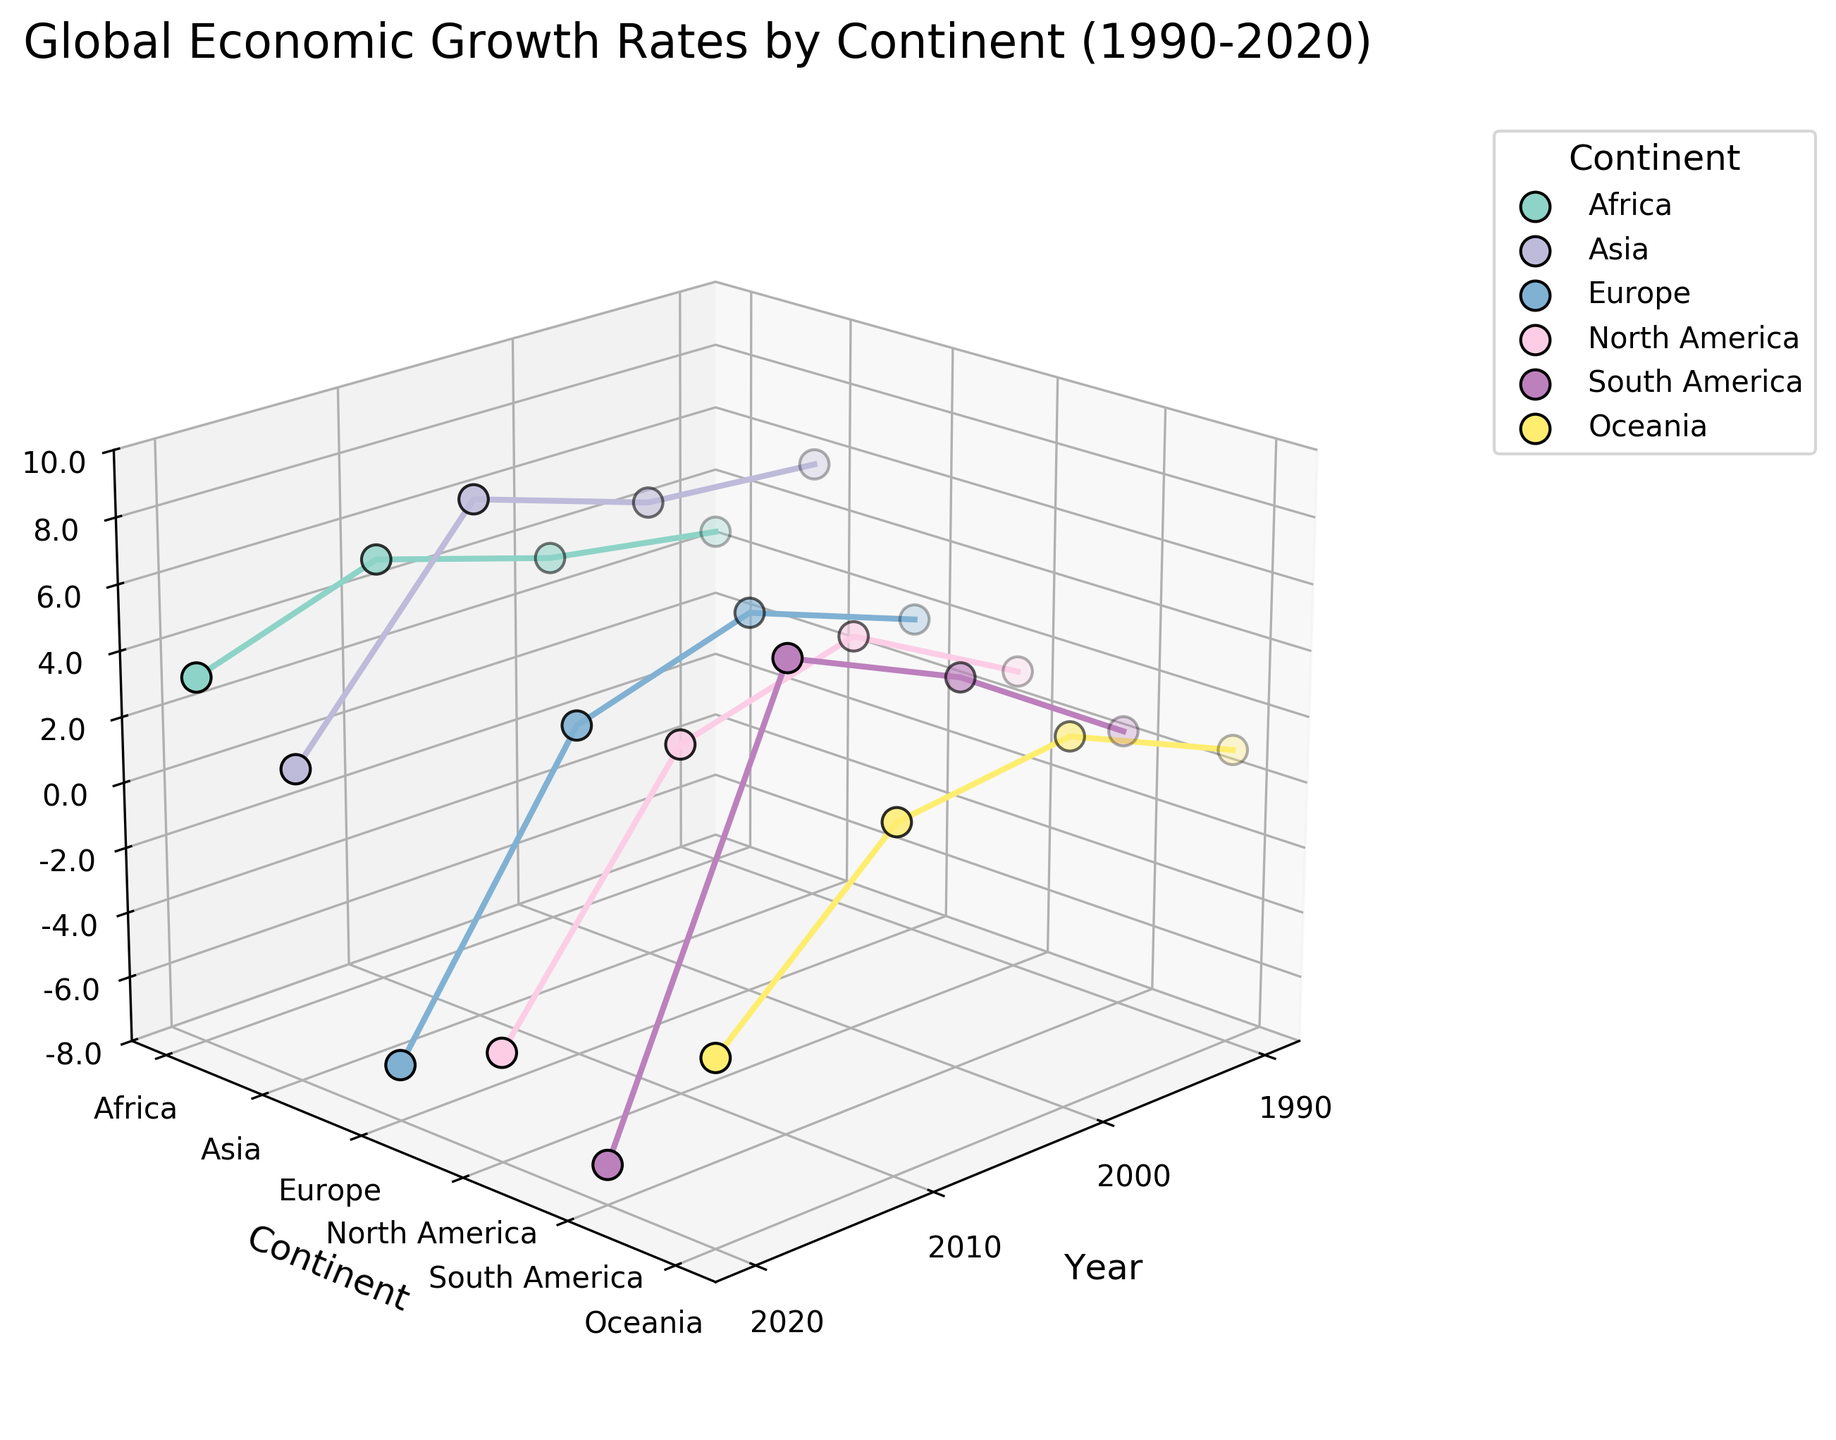What is the title of the figure? The title of the figure is displayed at the top of the plot. It is "Global Economic Growth Rates by Continent (1990-2020)."
Answer: Global Economic Growth Rates by Continent (1990-2020) Which continent had the highest growth rate in 2010? To determine this, look along the 2010 axis and compare the heights of the data points for each continent. The highest point in 2010 corresponds to Asia with a growth rate of 7.9%.
Answer: Asia What is the trend of growth rates for Africa from 1990 to 2020? Observe the data points plotted along the 1990 to 2020 range for Africa and note the changes in height. The growth rate for Africa increases from 2.7% in 1990 to 5.1% in 2010, then falls to 3.2% in 2020.
Answer: Increased then decreased Compare the growth rates of Europe and South America in 2020. Which continent had a higher growth rate? Find the 2020 data points for Europe and South America and compare their heights. Europe's growth rate is -6.3%, while South America's is -6.8%.
Answer: Europe What is the average growth rate for Oceania over the periods shown? Identify Oceania's growth rates from 1990 to 2020: 1.0%, 3.2%, 2.5%, -2.4%. Calculate the average: (1.0 + 3.2 + 2.5 - 2.4)/4 = 1.075%.
Answer: 1.075% Which decade showed the highest growth rate for North America? Look at the data points for North America across all decades and identify the highest one. The highest growth rate for North America is 4.1% in 2000.
Answer: 2000 Is there any continent that experienced negative growth in 2020? If yes, name them. Check the data points in 2020 for continents with a growth rate below 0. Europe, North America, South America, and Oceania have negative growth rates in 2020.
Answer: Europe, North America, South America, Oceania How did the growth rate of Asia change from 2010 to 2020? Observe the data points for Asia in 2010 and 2020. The growth rate decreased from 7.9% in 2010 to 1.5% in 2020.
Answer: Decreased Which continent shows the most stable growth rates over the years? Check the consistency in the heights of data points across years for each continent. Africa shows more stable growth with gradual changes compared to other continents.
Answer: Africa How many unique continents are represented in the plot? Look at the number of different labels on the y-axis, representing continents. There are six unique continents: Africa, Asia, Europe, North America, South America, and Oceania.
Answer: Six 